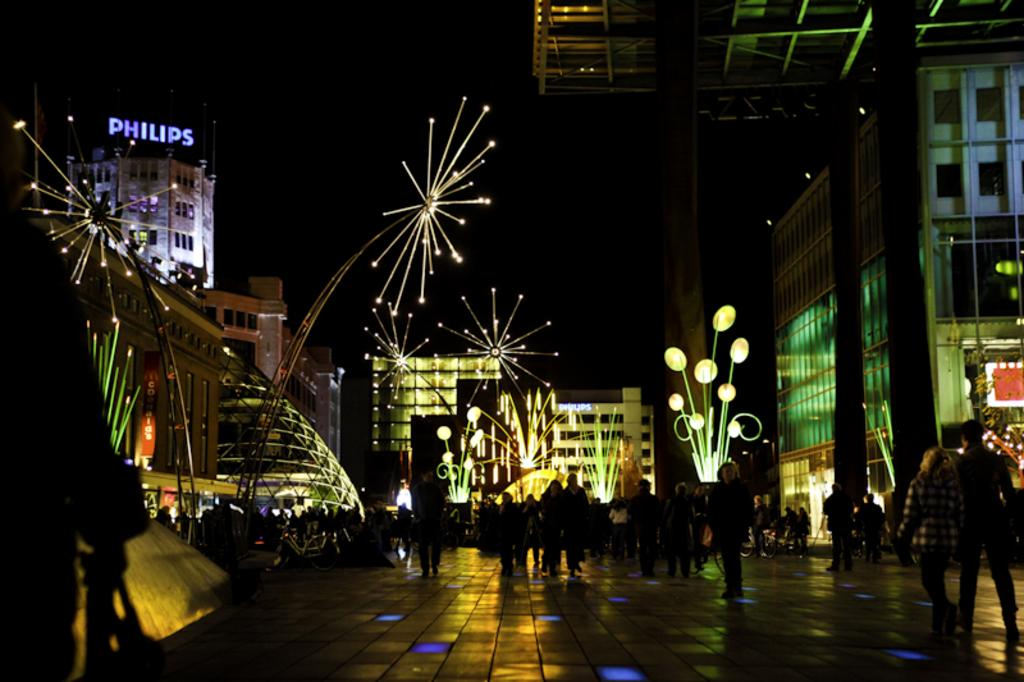What is happening with the group of people in the image? The group of people is on the ground in the image. What can be seen in the background of the image? Buildings are visible in the image. What is providing illumination in the image? Lights are present in the image. What structures are supporting the lights? Poles are visible in the image. What else can be seen in the image besides the people and lights? There are some objects in the image. How would you describe the overall lighting in the image? The background of the image appears to be dark. How many thumbs can be seen on the people in the image? There is no information about the number of thumbs visible on the people in the image. Is there a dock present in the image? There is no dock mentioned or visible in the image. 